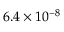Convert formula to latex. <formula><loc_0><loc_0><loc_500><loc_500>6 . 4 \times 1 0 ^ { - 8 }</formula> 